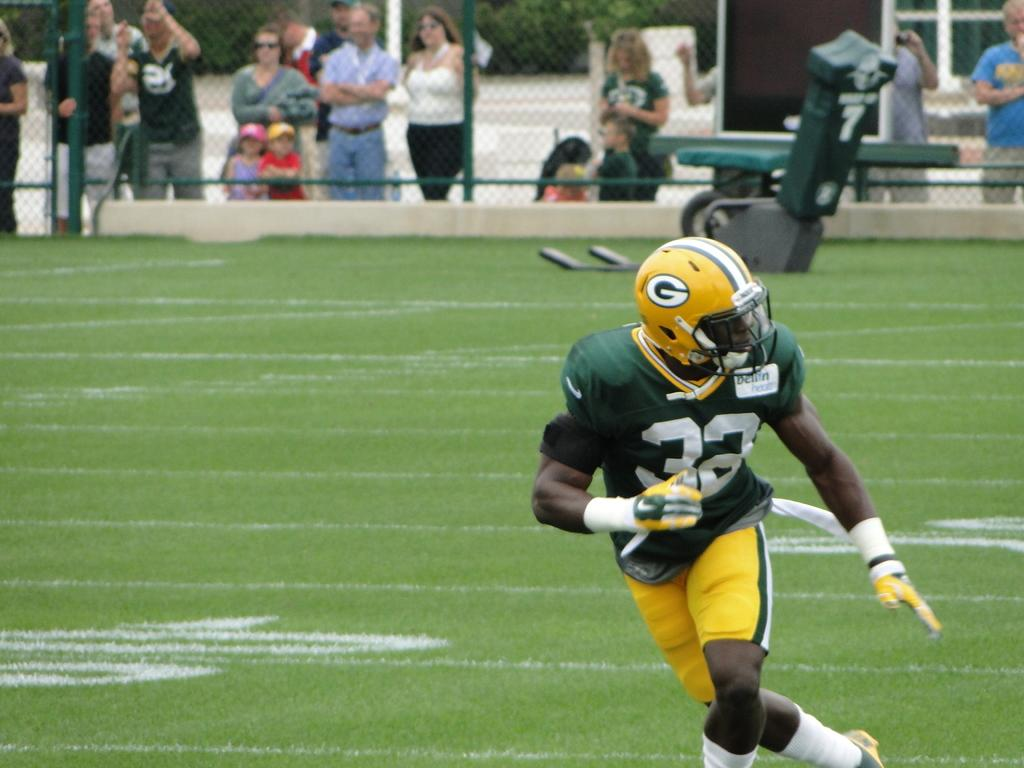What is the person in the image doing? There is a person running on the grass in the image. Can you describe the people near the fence? There are people standing near a fence in the image. What type of patch can be seen growing near the fence in the image? There is no patch visible in the image; it only features a person running on the grass and people standing near a fence. 